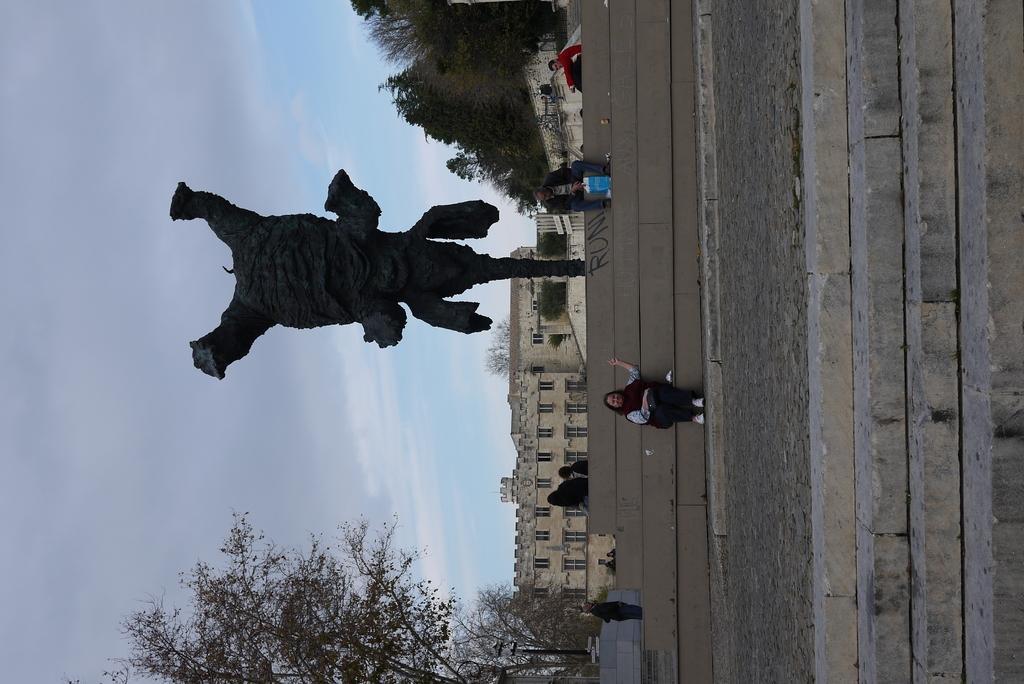In one or two sentences, can you explain what this image depicts? In this image there are people sitting on steps in front of sculpture, behind them there are trees and sculpture. 